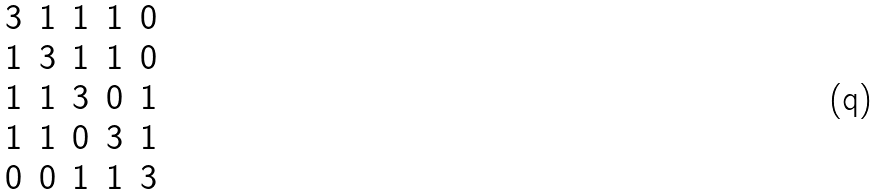<formula> <loc_0><loc_0><loc_500><loc_500>\begin{matrix} 3 & 1 & 1 & 1 & 0 \\ 1 & 3 & 1 & 1 & 0 \\ 1 & 1 & 3 & 0 & 1 \\ 1 & 1 & 0 & 3 & 1 \\ 0 & 0 & 1 & 1 & 3 \end{matrix}</formula> 